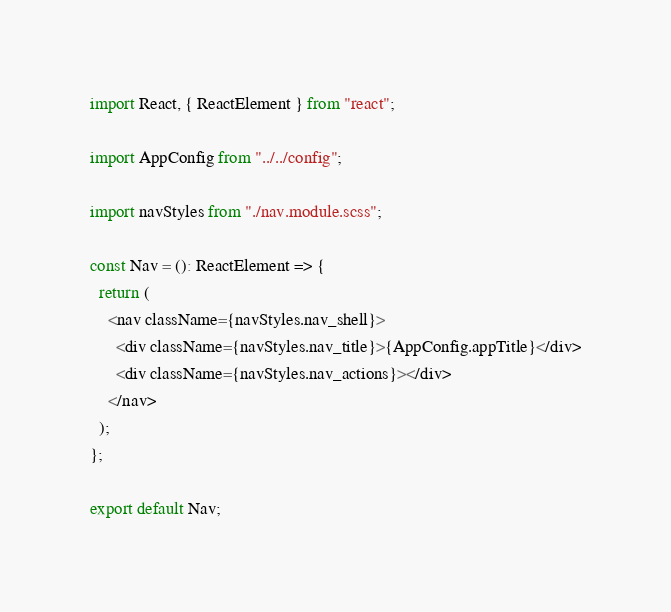Convert code to text. <code><loc_0><loc_0><loc_500><loc_500><_TypeScript_>import React, { ReactElement } from "react";

import AppConfig from "../../config";

import navStyles from "./nav.module.scss";

const Nav = (): ReactElement => {
  return (
    <nav className={navStyles.nav_shell}>
      <div className={navStyles.nav_title}>{AppConfig.appTitle}</div>
      <div className={navStyles.nav_actions}></div>
    </nav>
  );
};

export default Nav;
</code> 